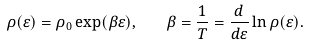Convert formula to latex. <formula><loc_0><loc_0><loc_500><loc_500>\rho ( \varepsilon ) = \rho _ { 0 } \exp ( \beta \varepsilon ) , \quad \beta = \frac { 1 } { T } = \frac { d } { d \varepsilon } \ln \rho ( \varepsilon ) .</formula> 